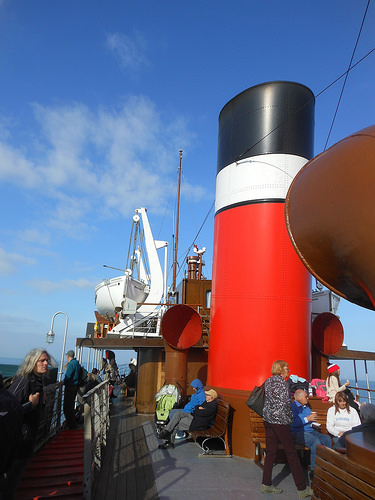<image>
Is the lady on the blue shirt? No. The lady is not positioned on the blue shirt. They may be near each other, but the lady is not supported by or resting on top of the blue shirt. 